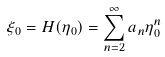<formula> <loc_0><loc_0><loc_500><loc_500>\xi _ { 0 } = H ( \eta _ { 0 } ) = \sum ^ { \infty } _ { n = 2 } a _ { n } \eta ^ { n } _ { 0 }</formula> 